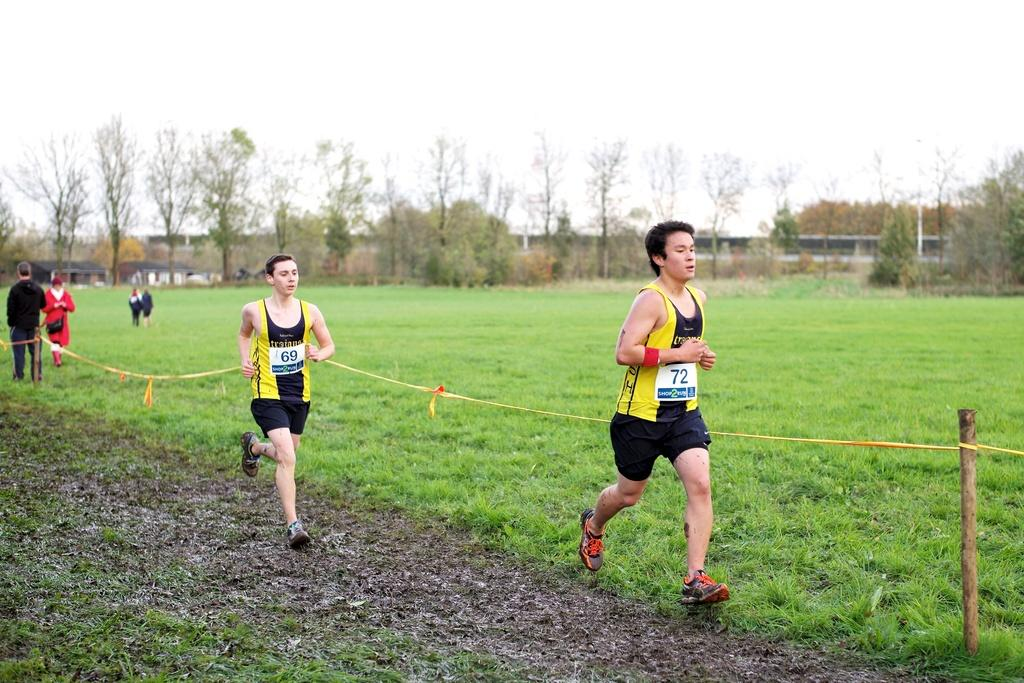<image>
Give a short and clear explanation of the subsequent image. In a foot race over muddy ground, contestant 72 is ahead of 69. 